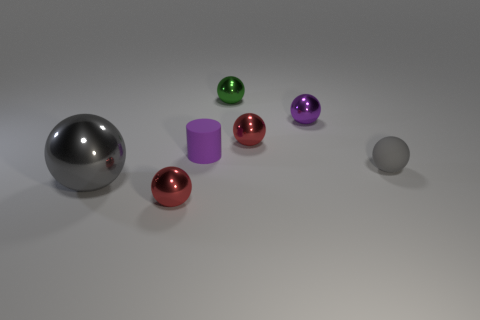Can you count the total number of colorful objects displayed? Certainly, there are a total of six colorful objects in the image: a large silver sphere, a smaller silver sphere, and four other smaller spheres in red, green, purple, and pink, along with a purple cylinder. 